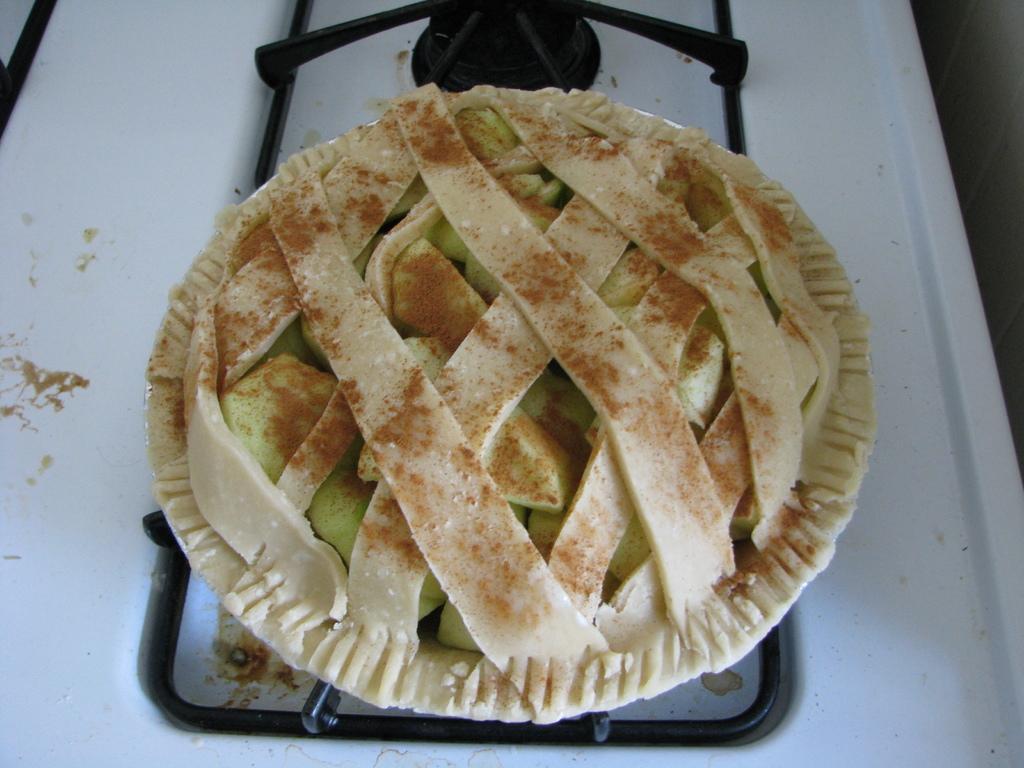In one or two sentences, can you explain what this image depicts? In this picture we can see food on stove. On the right side of the image we can see wall. 